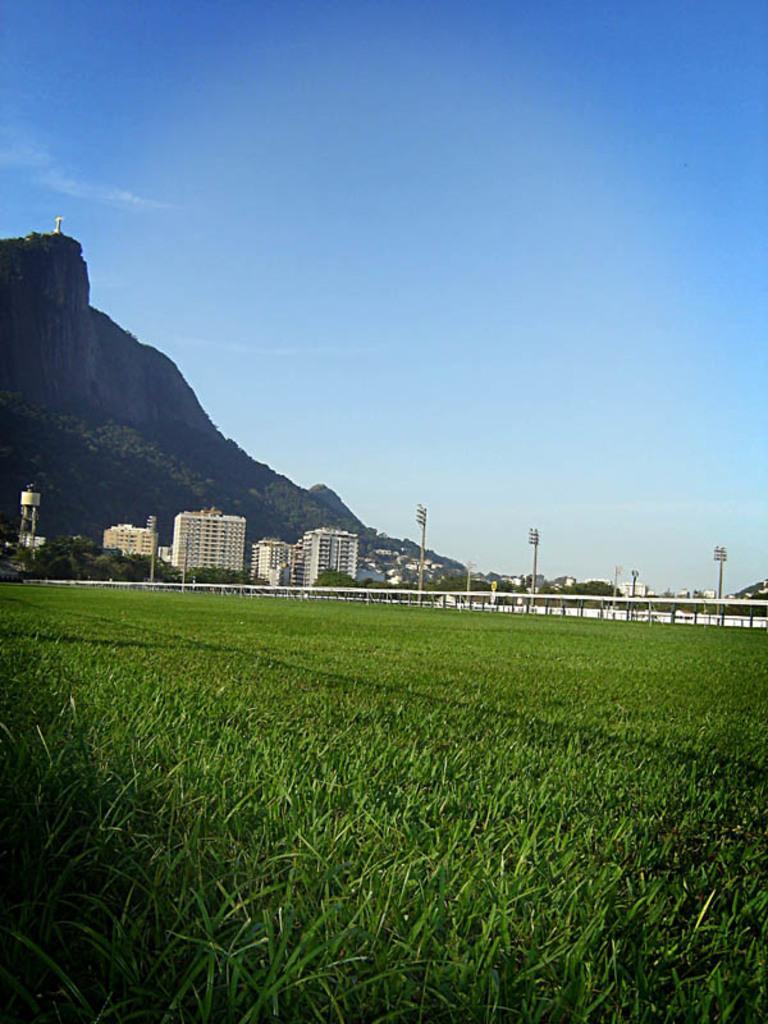In one or two sentences, can you explain what this image depicts? In this image I can see the grass. To the side of the grass I can see the railing and the poles. In the background I can see many buildings, mountains and the sky. 